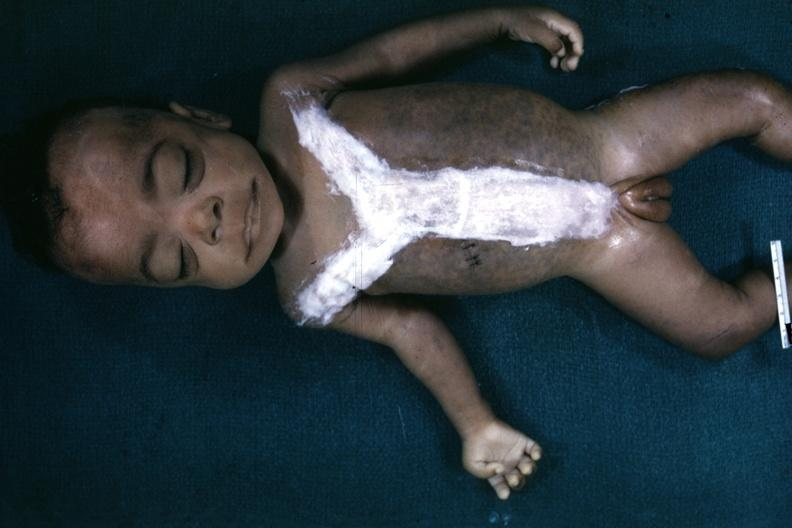when does this image show whole body?
Answer the question using a single word or phrase. After autopsy with covered incision very good representation of mongoloid facies and one hand is opened to simian crease quite good example 